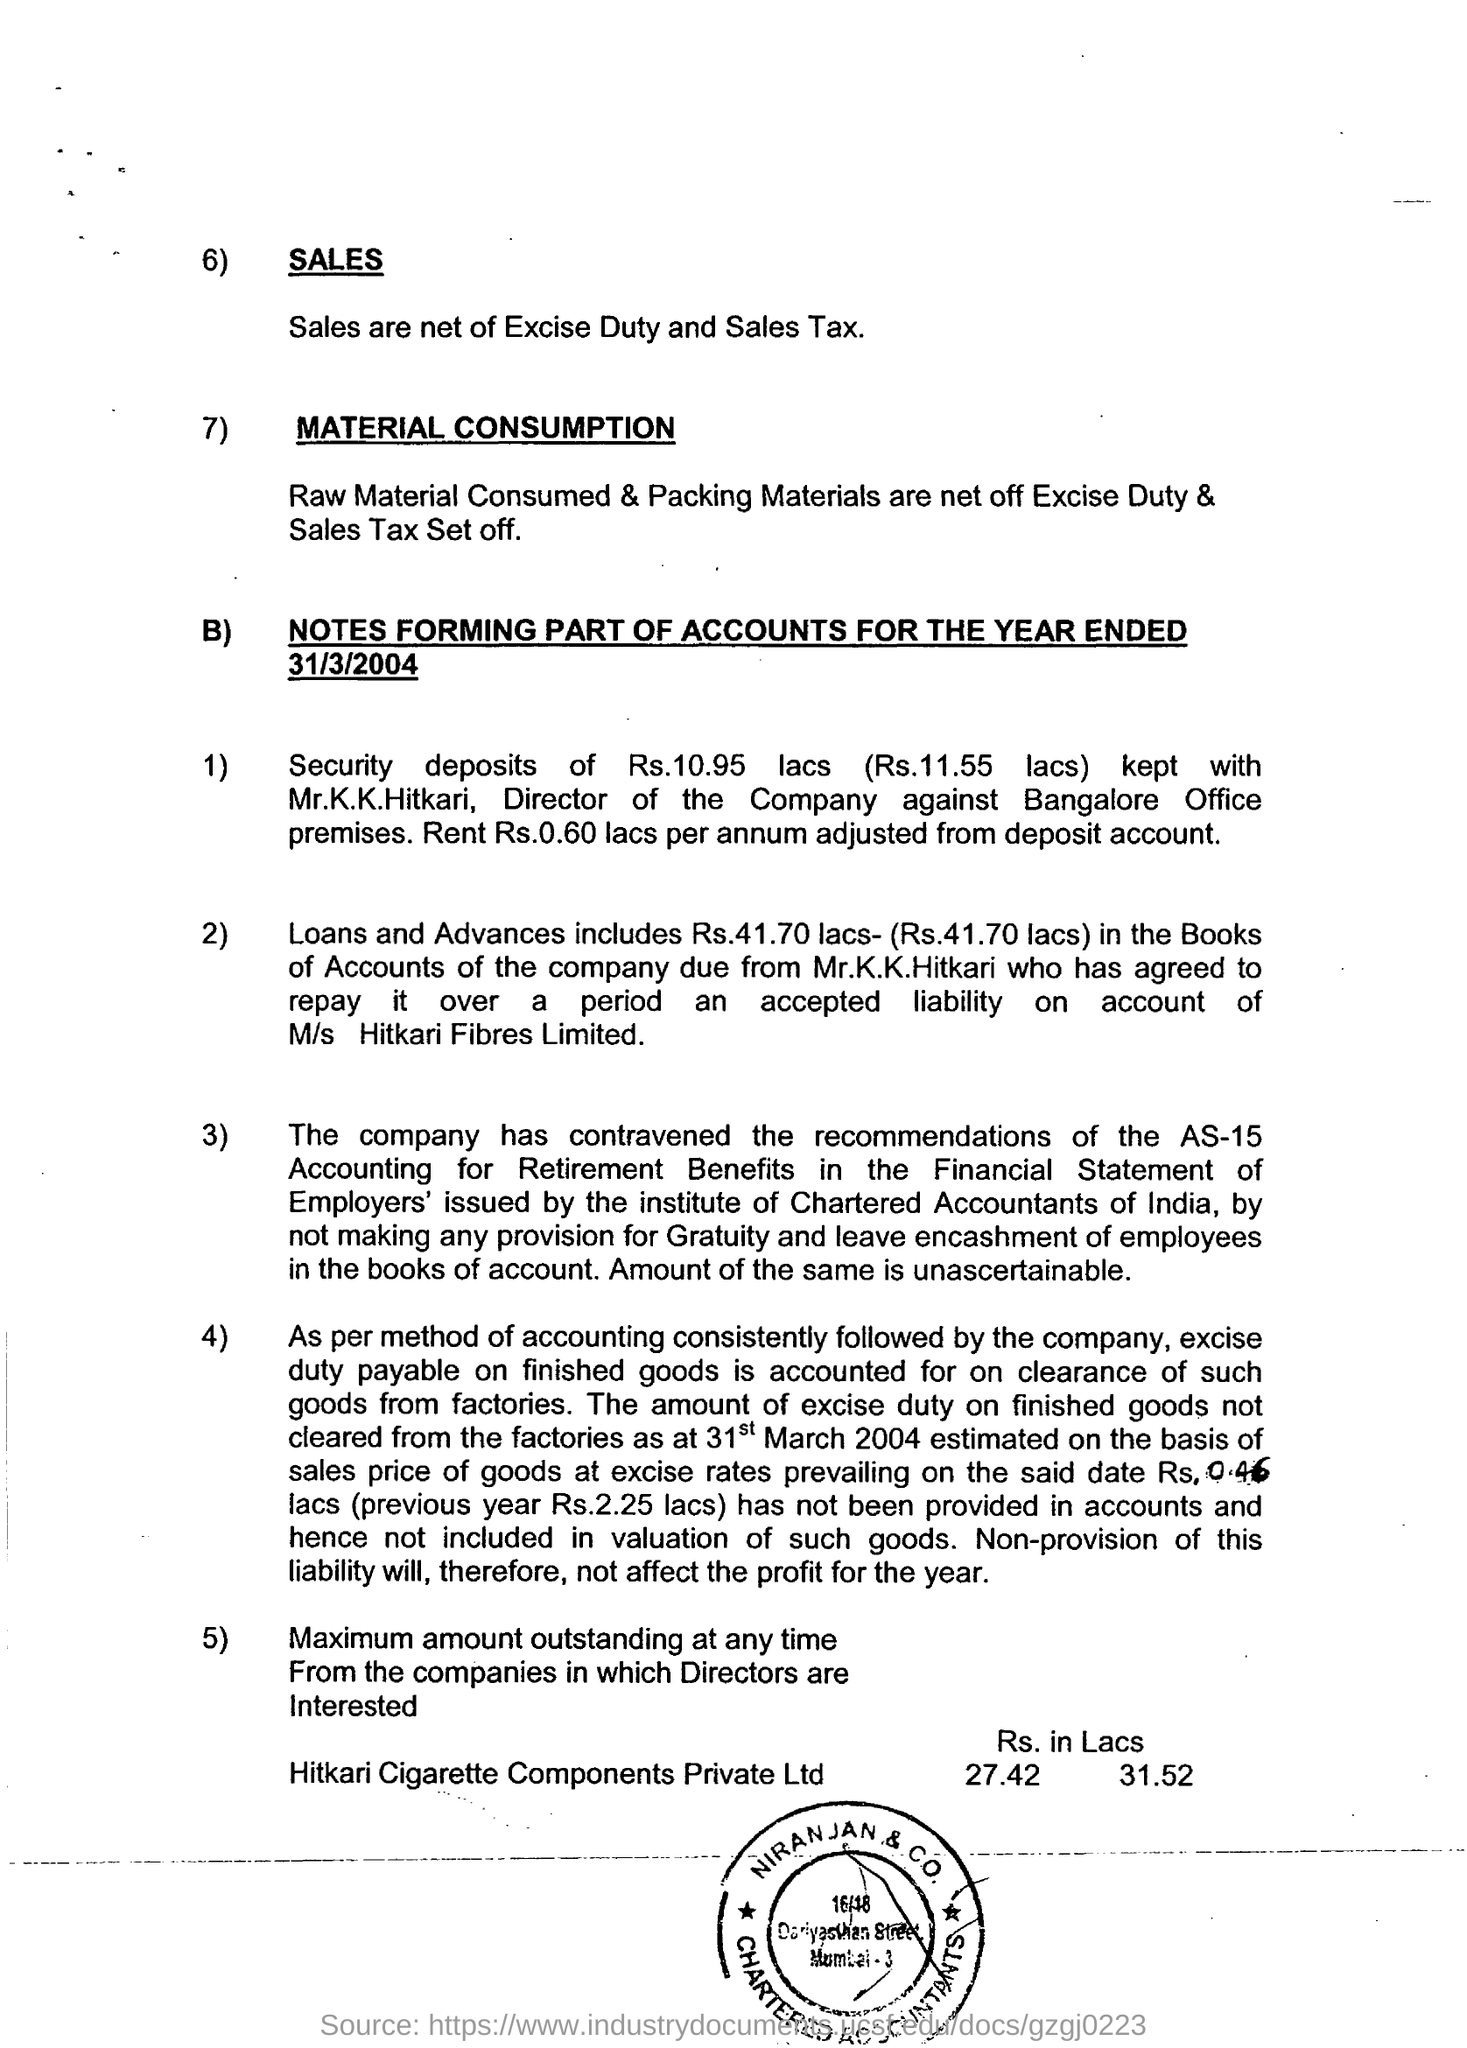Mention a couple of crucial points in this snapshot. The company has violated the guidelines outlined in AS 15 accounting for retirement benefits, as recommended by the Accounting Standards Board. 